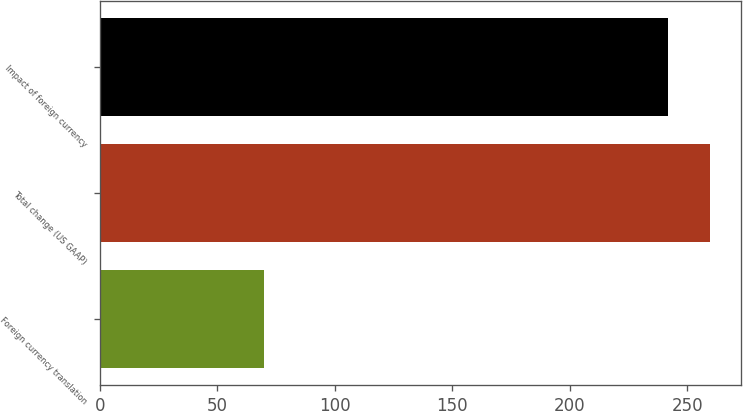Convert chart to OTSL. <chart><loc_0><loc_0><loc_500><loc_500><bar_chart><fcel>Foreign currency translation<fcel>Total change (US GAAP)<fcel>Impact of foreign currency<nl><fcel>69.9<fcel>259.74<fcel>242<nl></chart> 